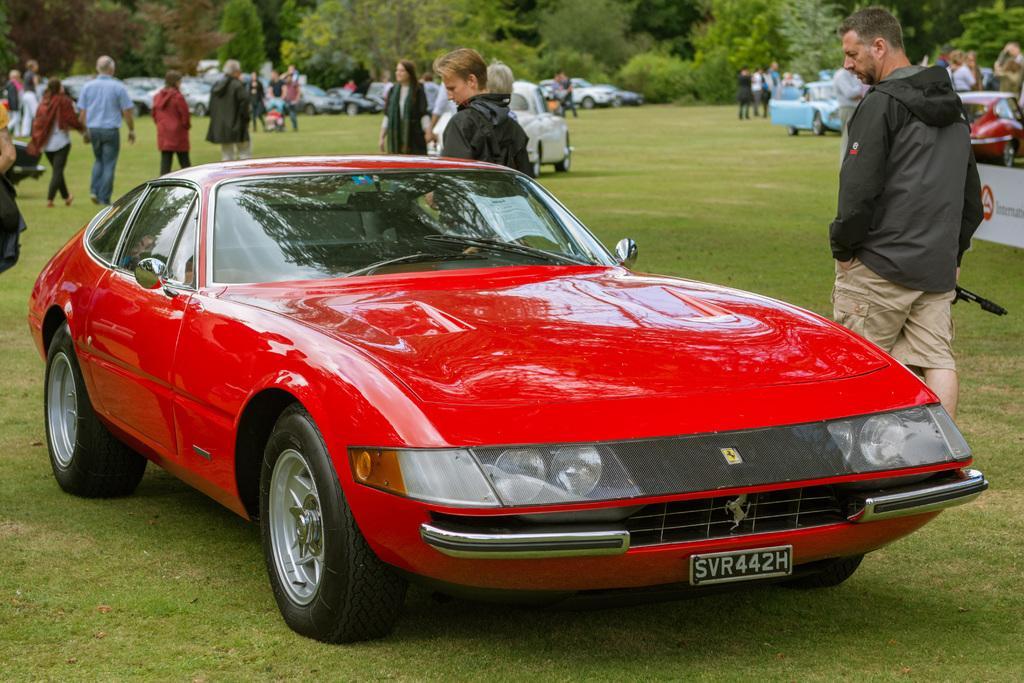Could you give a brief overview of what you see in this image? In this image I can see a vehicle in red color. Background I can see group of people walking and few vehicles and I can see trees in green color. 